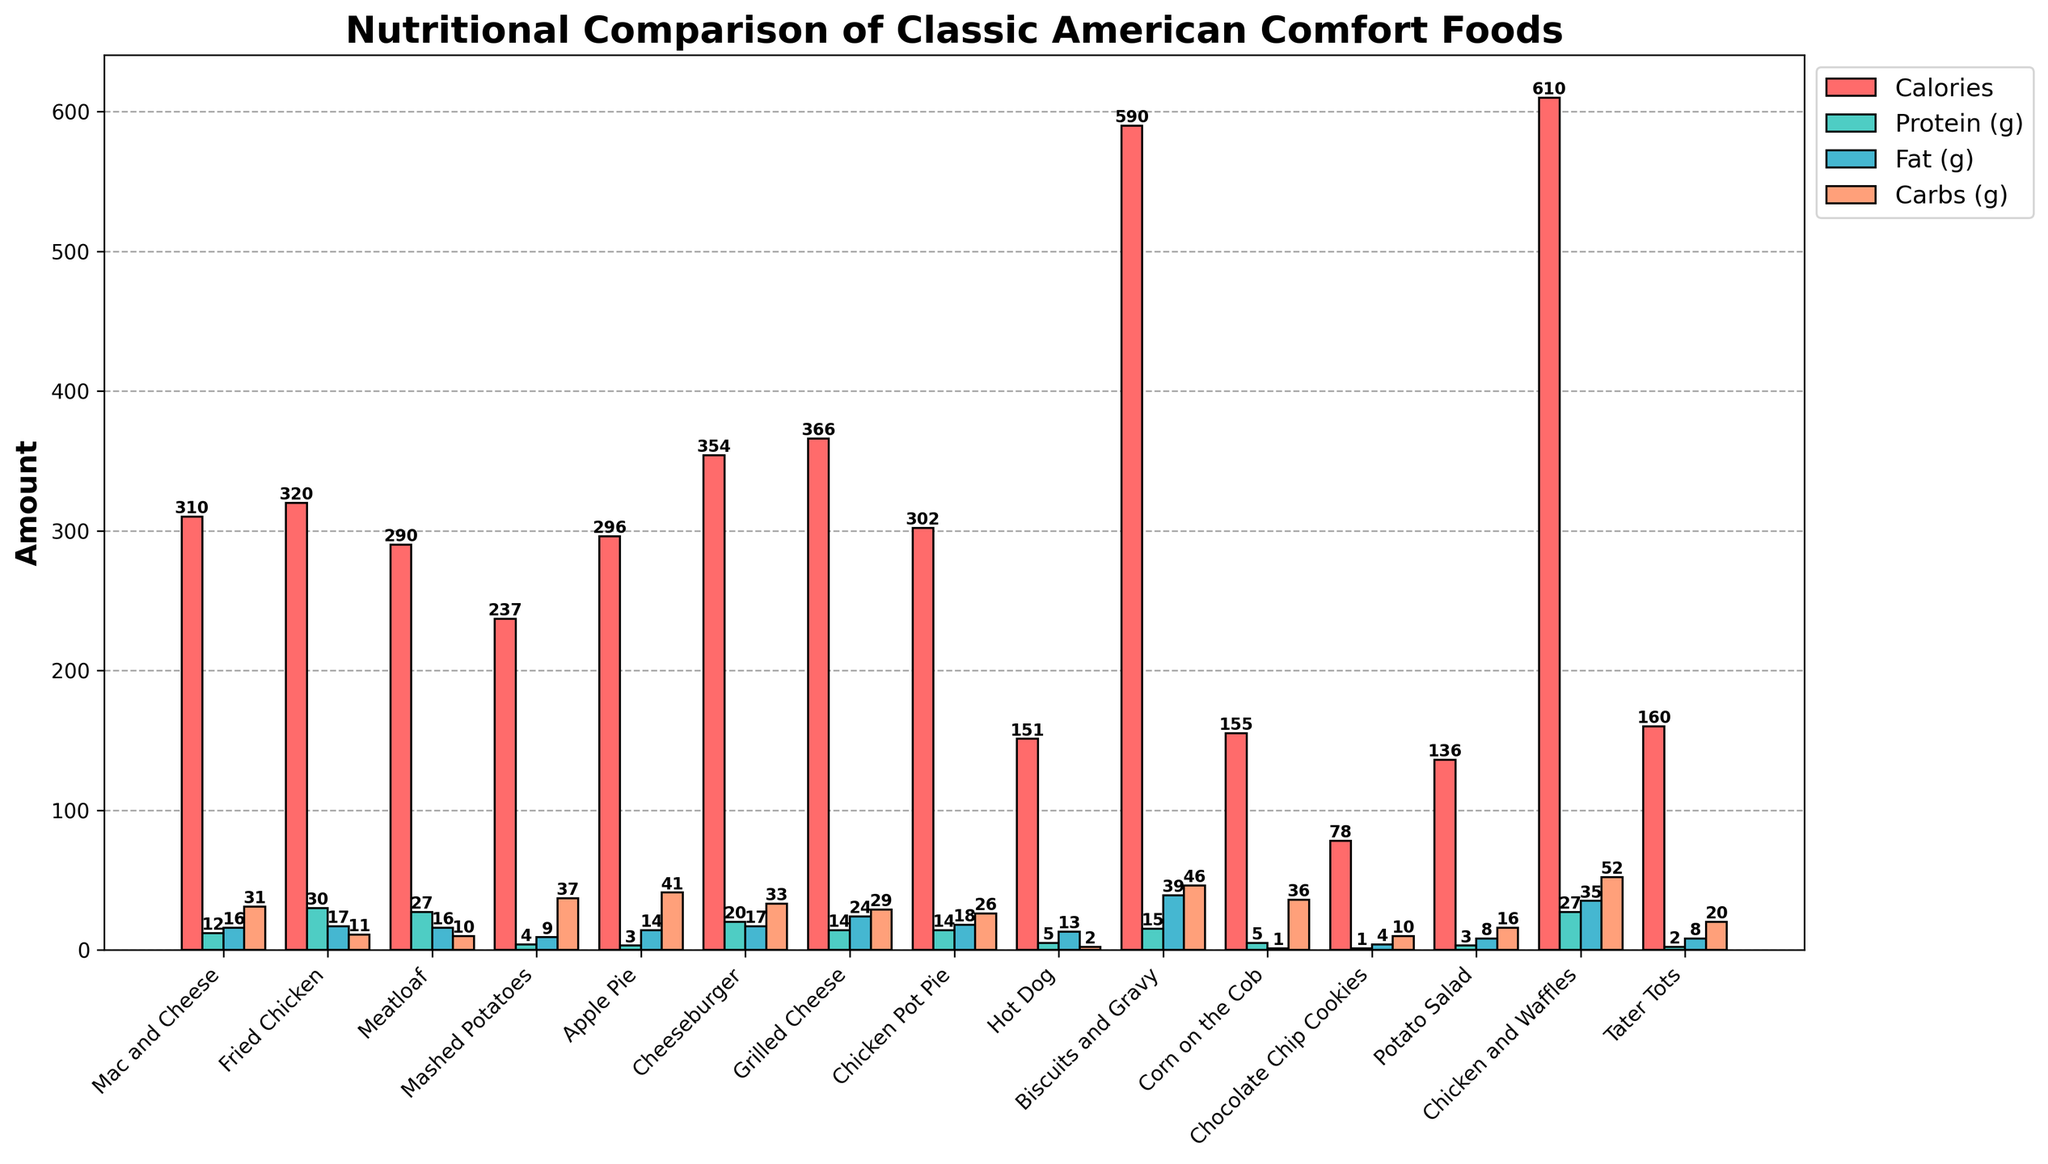Which food item has the highest amount of calories? We can identify the food item with the highest calorie bar by looking at the tallest red bar.
Answer: Chicken and Waffles How much more protein does Fried Chicken have compared to Mac and Cheese? Check the height of the green bars for both Fried Chicken and Mac and Cheese and subtract the protein value of Mac and Cheese (12) from that of Fried Chicken (30). 30 - 12 = 18
Answer: 18g Which food has the lowest number of carbs? Identify the food item with the shortest orange bar when compared to the carbs of other foods.
Answer: Hot Dog Between Cheeseburger and Chicken Pot Pie, which one has higher fat content? Compare the height of the blue fat bars for both Cheeseburger and Chicken Pot Pie. Cheeseburger has 17g of fat, and Chicken Pot Pie has 18g.
Answer: Chicken Pot Pie What is the sum of carbs in Apple Pie and Chocolate Chip Cookies? Sum the carb values for Apple Pie (41) and Chocolate Chip Cookies (10). 41 + 10 = 51
Answer: 51g What is the average calorie content of Mac and Cheese, Meatloaf, and Mashed Potatoes? Add the calorie values of Mac and Cheese (310), Meatloaf (290), and Mashed Potatoes (237), and divide by the number of items. (310 + 290 + 237) / 3 = 279
Answer: 279 Which food item has the most balanced amount of calories, protein, fat, and carbs? Look for the food item where the red, green, blue, and orange bars resemble similar heights, indicating a balance.
Answer: Chicken Pot Pie Compare the fat content in Tater Tots and Potato Salad. Which one is lower, and by how much? Tater Tots have 8g of fat, and Potato Salad has 8g of fat. Subtract one from the other to find the difference: 8 - 8 = 0.
Answer: Equal (no difference) What is the difference in carbs between Chicken and Waffles and Corn on the Cob? Subtract the carb value of Corn on the Cob (36) from that of Chicken and Waffles (52). 52 - 36 = 16
Answer: 16g 